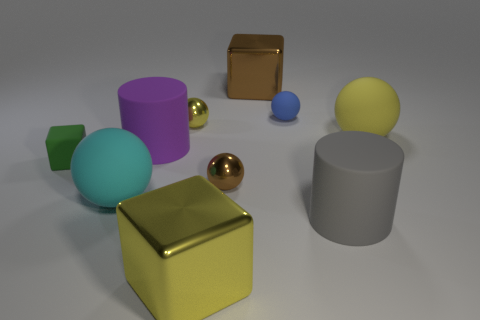What number of gray objects are either large rubber cylinders or small things?
Your answer should be very brief. 1. The matte block is what color?
Make the answer very short. Green. Is the number of small blue balls on the right side of the blue thing less than the number of tiny green matte cubes that are in front of the large yellow sphere?
Keep it short and to the point. Yes. There is a yellow thing that is both in front of the small yellow shiny thing and to the left of the big brown metal object; what shape is it?
Your answer should be very brief. Cube. What number of purple rubber things are the same shape as the big gray matte thing?
Offer a very short reply. 1. The cube that is made of the same material as the blue sphere is what size?
Your answer should be compact. Small. What number of green cubes have the same size as the yellow metal sphere?
Keep it short and to the point. 1. There is a cylinder left of the small sphere in front of the tiny yellow metallic object; what is its color?
Your response must be concise. Purple. There is a matte cube that is the same size as the blue sphere; what is its color?
Provide a short and direct response. Green. Is the material of the big cylinder in front of the green cube the same as the green object?
Your answer should be very brief. Yes. 